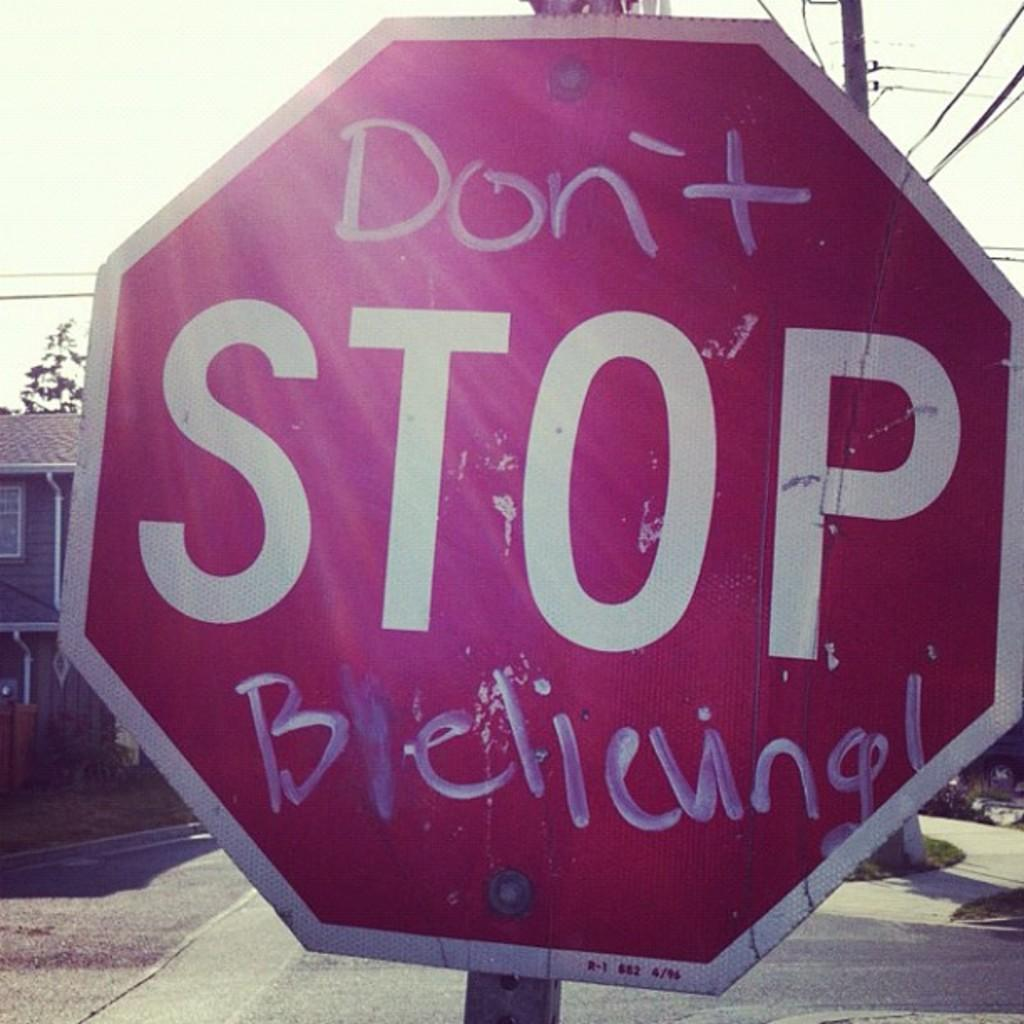<image>
Offer a succinct explanation of the picture presented. A stop sign that has graffiti etched on it that says Don't  Believing. 